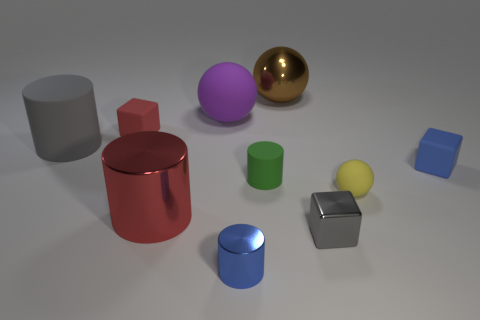Subtract all brown cylinders. Subtract all green spheres. How many cylinders are left? 4 Subtract all spheres. How many objects are left? 7 Add 5 big objects. How many big objects are left? 9 Add 1 small gray shiny cubes. How many small gray shiny cubes exist? 2 Subtract 0 blue spheres. How many objects are left? 10 Subtract all big yellow spheres. Subtract all metal cylinders. How many objects are left? 8 